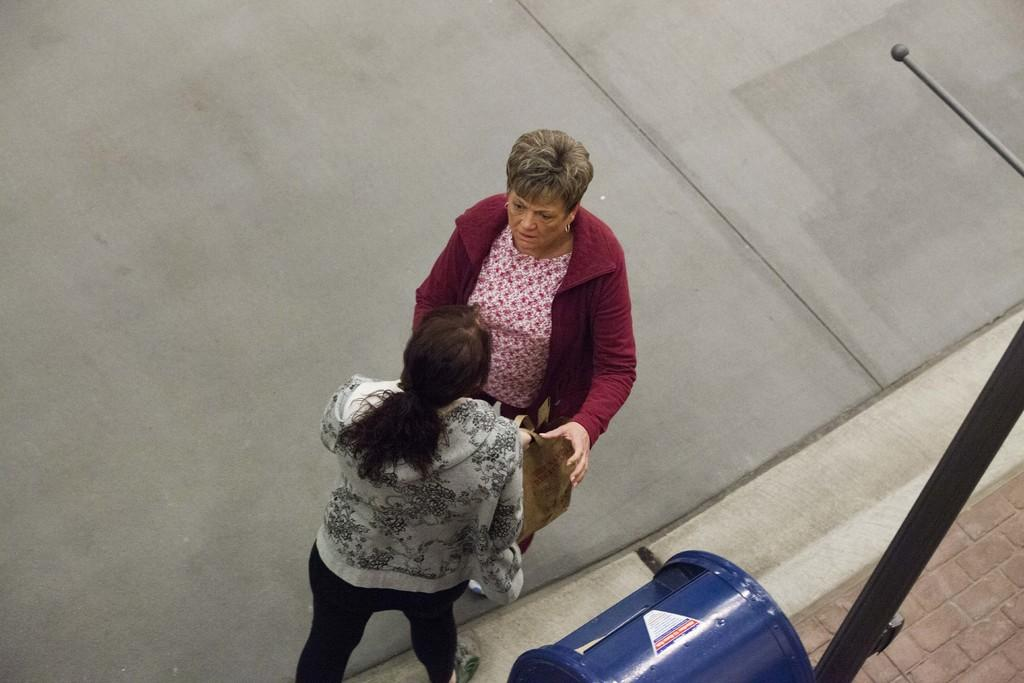What is the color of the object in the foreground of the image? The object in the foreground of the image is blue. What can be seen on the right side of the image? There is a pole on the right side of the image. How many women are standing on the road in the image? Two women are standing on the road in the image. What is one of the women holding? One woman is holding a bag. Can you touch the self in the image? There is no self or representation of a person's identity present in the image. 